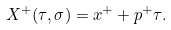<formula> <loc_0><loc_0><loc_500><loc_500>X ^ { + } ( \tau , \sigma ) = x ^ { + } + p ^ { + } \tau .</formula> 